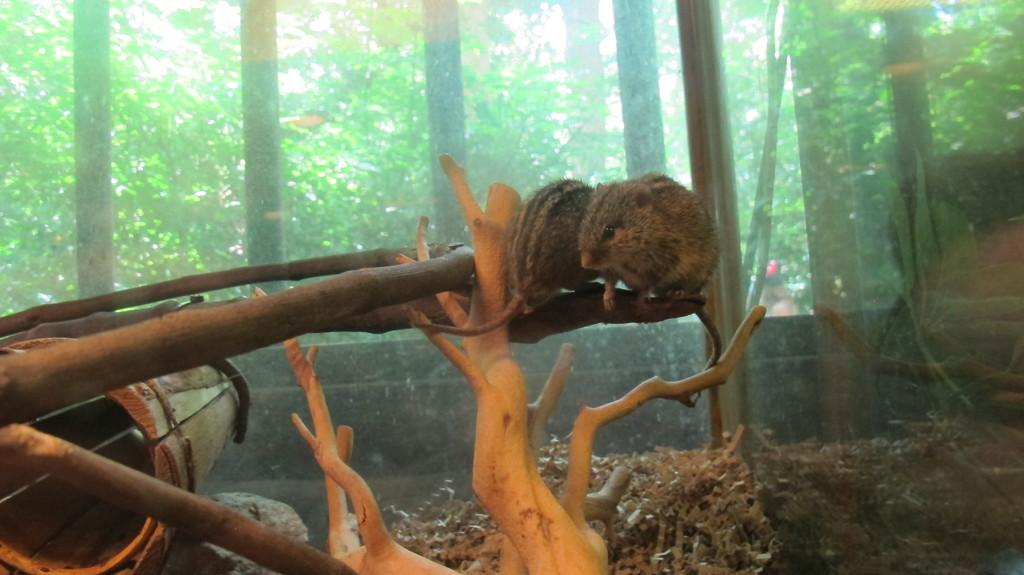What animal is present in the image? There is a squirrel in the image. Where is the squirrel located? The squirrel is sitting on a tree branch. What can be seen in the background of the image? There are trees and a sky visible in the background of the image. Are there any structures or objects in the background? Yes, there are grills in the background of the image. Where is the library located in the image? There is no library present in the image. What type of ornament is hanging from the tree branch? There is no ornament hanging from the tree branch in the image; only the squirrel is present. 